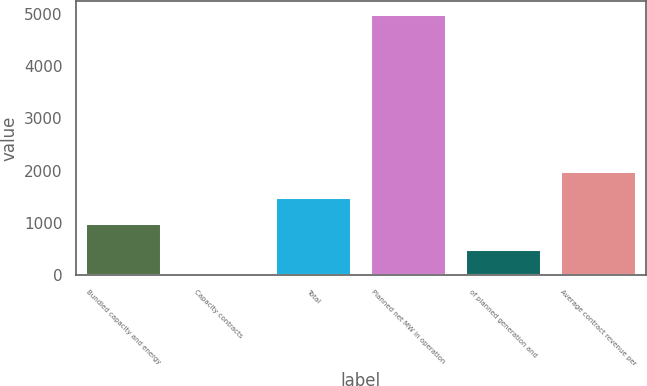Convert chart. <chart><loc_0><loc_0><loc_500><loc_500><bar_chart><fcel>Bundled capacity and energy<fcel>Capacity contracts<fcel>Total<fcel>Planned net MW in operation<fcel>of planned generation and<fcel>Average contract revenue per<nl><fcel>1003.28<fcel>4.6<fcel>1502.62<fcel>4998<fcel>503.94<fcel>2001.96<nl></chart> 